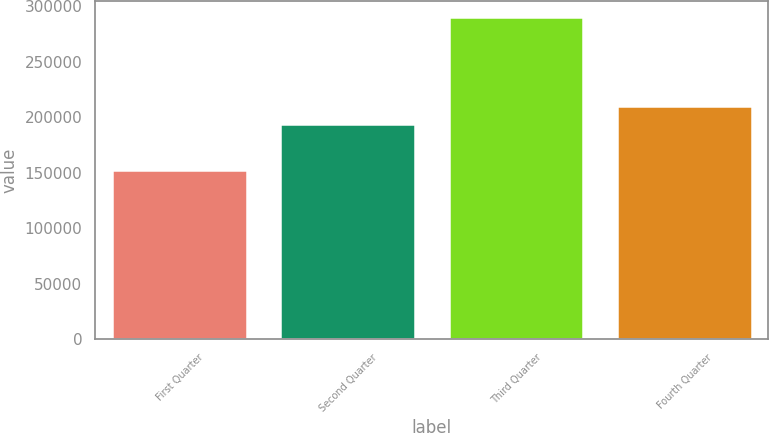Convert chart to OTSL. <chart><loc_0><loc_0><loc_500><loc_500><bar_chart><fcel>First Quarter<fcel>Second Quarter<fcel>Third Quarter<fcel>Fourth Quarter<nl><fcel>152648<fcel>193779<fcel>290089<fcel>210325<nl></chart> 